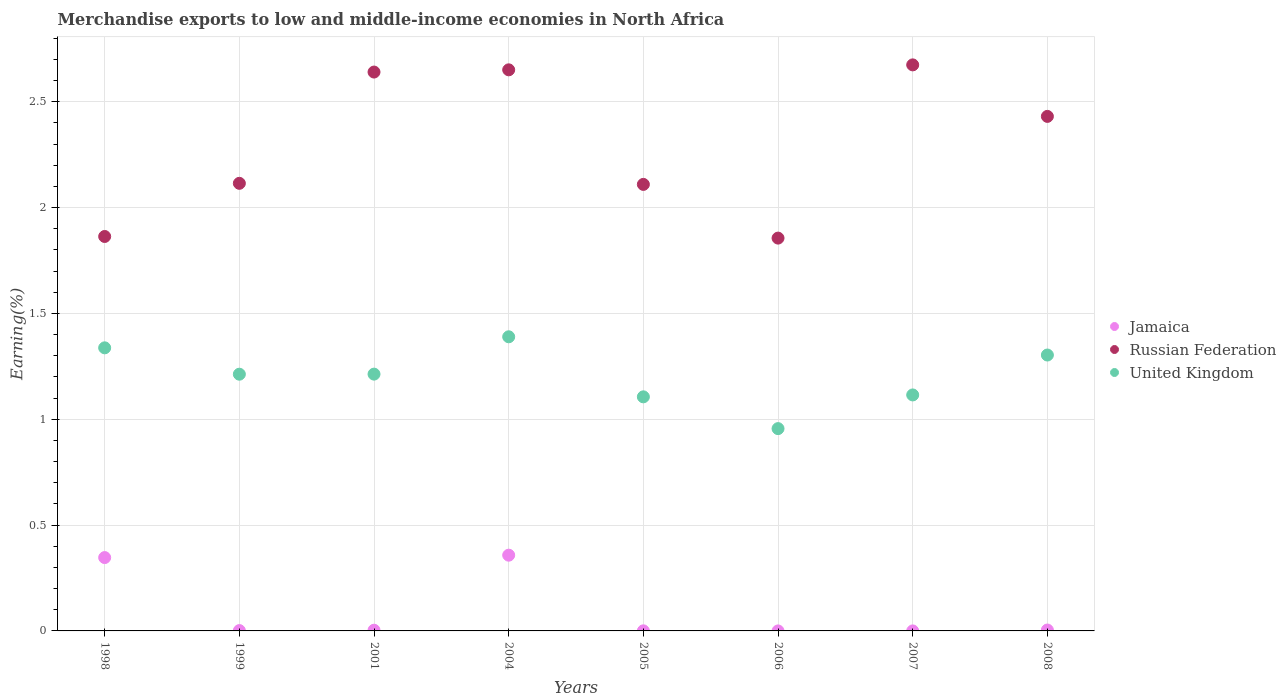What is the percentage of amount earned from merchandise exports in Russian Federation in 2004?
Your response must be concise. 2.65. Across all years, what is the maximum percentage of amount earned from merchandise exports in Russian Federation?
Make the answer very short. 2.67. Across all years, what is the minimum percentage of amount earned from merchandise exports in Jamaica?
Give a very brief answer. 6.24280726533135e-6. In which year was the percentage of amount earned from merchandise exports in Russian Federation maximum?
Offer a terse response. 2007. In which year was the percentage of amount earned from merchandise exports in Russian Federation minimum?
Keep it short and to the point. 2006. What is the total percentage of amount earned from merchandise exports in Jamaica in the graph?
Offer a very short reply. 0.71. What is the difference between the percentage of amount earned from merchandise exports in United Kingdom in 2001 and that in 2004?
Make the answer very short. -0.18. What is the difference between the percentage of amount earned from merchandise exports in Russian Federation in 2006 and the percentage of amount earned from merchandise exports in Jamaica in 1999?
Make the answer very short. 1.85. What is the average percentage of amount earned from merchandise exports in Jamaica per year?
Offer a very short reply. 0.09. In the year 2004, what is the difference between the percentage of amount earned from merchandise exports in Russian Federation and percentage of amount earned from merchandise exports in Jamaica?
Your answer should be compact. 2.29. What is the ratio of the percentage of amount earned from merchandise exports in Russian Federation in 1998 to that in 1999?
Ensure brevity in your answer.  0.88. What is the difference between the highest and the second highest percentage of amount earned from merchandise exports in Russian Federation?
Give a very brief answer. 0.02. What is the difference between the highest and the lowest percentage of amount earned from merchandise exports in Russian Federation?
Ensure brevity in your answer.  0.82. In how many years, is the percentage of amount earned from merchandise exports in Russian Federation greater than the average percentage of amount earned from merchandise exports in Russian Federation taken over all years?
Give a very brief answer. 4. Is the sum of the percentage of amount earned from merchandise exports in Jamaica in 1999 and 2004 greater than the maximum percentage of amount earned from merchandise exports in Russian Federation across all years?
Provide a succinct answer. No. Does the percentage of amount earned from merchandise exports in Russian Federation monotonically increase over the years?
Offer a terse response. No. Is the percentage of amount earned from merchandise exports in Jamaica strictly less than the percentage of amount earned from merchandise exports in Russian Federation over the years?
Provide a short and direct response. Yes. How many dotlines are there?
Offer a terse response. 3. How many years are there in the graph?
Your answer should be very brief. 8. What is the difference between two consecutive major ticks on the Y-axis?
Your answer should be compact. 0.5. Are the values on the major ticks of Y-axis written in scientific E-notation?
Offer a very short reply. No. Does the graph contain any zero values?
Keep it short and to the point. No. Does the graph contain grids?
Your response must be concise. Yes. Where does the legend appear in the graph?
Offer a terse response. Center right. How are the legend labels stacked?
Provide a short and direct response. Vertical. What is the title of the graph?
Your response must be concise. Merchandise exports to low and middle-income economies in North Africa. Does "Czech Republic" appear as one of the legend labels in the graph?
Make the answer very short. No. What is the label or title of the Y-axis?
Keep it short and to the point. Earning(%). What is the Earning(%) of Jamaica in 1998?
Your response must be concise. 0.35. What is the Earning(%) in Russian Federation in 1998?
Make the answer very short. 1.86. What is the Earning(%) of United Kingdom in 1998?
Offer a very short reply. 1.34. What is the Earning(%) in Jamaica in 1999?
Provide a short and direct response. 0. What is the Earning(%) of Russian Federation in 1999?
Make the answer very short. 2.11. What is the Earning(%) of United Kingdom in 1999?
Ensure brevity in your answer.  1.21. What is the Earning(%) of Jamaica in 2001?
Offer a terse response. 0. What is the Earning(%) in Russian Federation in 2001?
Ensure brevity in your answer.  2.64. What is the Earning(%) in United Kingdom in 2001?
Make the answer very short. 1.21. What is the Earning(%) of Jamaica in 2004?
Provide a short and direct response. 0.36. What is the Earning(%) of Russian Federation in 2004?
Make the answer very short. 2.65. What is the Earning(%) of United Kingdom in 2004?
Offer a terse response. 1.39. What is the Earning(%) in Jamaica in 2005?
Your response must be concise. 0. What is the Earning(%) of Russian Federation in 2005?
Offer a terse response. 2.11. What is the Earning(%) in United Kingdom in 2005?
Your response must be concise. 1.11. What is the Earning(%) of Jamaica in 2006?
Your answer should be compact. 6.24280726533135e-6. What is the Earning(%) in Russian Federation in 2006?
Give a very brief answer. 1.86. What is the Earning(%) of United Kingdom in 2006?
Offer a very short reply. 0.96. What is the Earning(%) in Jamaica in 2007?
Provide a short and direct response. 2.32928039792183e-5. What is the Earning(%) in Russian Federation in 2007?
Offer a very short reply. 2.67. What is the Earning(%) in United Kingdom in 2007?
Offer a terse response. 1.11. What is the Earning(%) in Jamaica in 2008?
Give a very brief answer. 0. What is the Earning(%) in Russian Federation in 2008?
Offer a very short reply. 2.43. What is the Earning(%) in United Kingdom in 2008?
Your response must be concise. 1.3. Across all years, what is the maximum Earning(%) in Jamaica?
Your response must be concise. 0.36. Across all years, what is the maximum Earning(%) of Russian Federation?
Your answer should be very brief. 2.67. Across all years, what is the maximum Earning(%) of United Kingdom?
Your answer should be compact. 1.39. Across all years, what is the minimum Earning(%) of Jamaica?
Your response must be concise. 6.24280726533135e-6. Across all years, what is the minimum Earning(%) of Russian Federation?
Ensure brevity in your answer.  1.86. Across all years, what is the minimum Earning(%) in United Kingdom?
Keep it short and to the point. 0.96. What is the total Earning(%) in Jamaica in the graph?
Your answer should be very brief. 0.71. What is the total Earning(%) in Russian Federation in the graph?
Give a very brief answer. 18.34. What is the total Earning(%) of United Kingdom in the graph?
Provide a succinct answer. 9.63. What is the difference between the Earning(%) of Jamaica in 1998 and that in 1999?
Your response must be concise. 0.34. What is the difference between the Earning(%) of Russian Federation in 1998 and that in 1999?
Your response must be concise. -0.25. What is the difference between the Earning(%) of United Kingdom in 1998 and that in 1999?
Give a very brief answer. 0.12. What is the difference between the Earning(%) in Jamaica in 1998 and that in 2001?
Provide a succinct answer. 0.34. What is the difference between the Earning(%) of Russian Federation in 1998 and that in 2001?
Provide a succinct answer. -0.78. What is the difference between the Earning(%) in United Kingdom in 1998 and that in 2001?
Your answer should be compact. 0.12. What is the difference between the Earning(%) in Jamaica in 1998 and that in 2004?
Your answer should be very brief. -0.01. What is the difference between the Earning(%) in Russian Federation in 1998 and that in 2004?
Ensure brevity in your answer.  -0.79. What is the difference between the Earning(%) of United Kingdom in 1998 and that in 2004?
Keep it short and to the point. -0.05. What is the difference between the Earning(%) in Jamaica in 1998 and that in 2005?
Give a very brief answer. 0.35. What is the difference between the Earning(%) of Russian Federation in 1998 and that in 2005?
Your answer should be compact. -0.25. What is the difference between the Earning(%) of United Kingdom in 1998 and that in 2005?
Ensure brevity in your answer.  0.23. What is the difference between the Earning(%) in Jamaica in 1998 and that in 2006?
Give a very brief answer. 0.35. What is the difference between the Earning(%) of Russian Federation in 1998 and that in 2006?
Offer a terse response. 0.01. What is the difference between the Earning(%) in United Kingdom in 1998 and that in 2006?
Your answer should be very brief. 0.38. What is the difference between the Earning(%) in Jamaica in 1998 and that in 2007?
Your response must be concise. 0.35. What is the difference between the Earning(%) in Russian Federation in 1998 and that in 2007?
Your answer should be compact. -0.81. What is the difference between the Earning(%) in United Kingdom in 1998 and that in 2007?
Your answer should be compact. 0.22. What is the difference between the Earning(%) in Jamaica in 1998 and that in 2008?
Your response must be concise. 0.34. What is the difference between the Earning(%) in Russian Federation in 1998 and that in 2008?
Your answer should be compact. -0.57. What is the difference between the Earning(%) of United Kingdom in 1998 and that in 2008?
Make the answer very short. 0.03. What is the difference between the Earning(%) of Jamaica in 1999 and that in 2001?
Your answer should be compact. -0. What is the difference between the Earning(%) in Russian Federation in 1999 and that in 2001?
Give a very brief answer. -0.53. What is the difference between the Earning(%) of United Kingdom in 1999 and that in 2001?
Offer a very short reply. -0. What is the difference between the Earning(%) of Jamaica in 1999 and that in 2004?
Offer a very short reply. -0.36. What is the difference between the Earning(%) in Russian Federation in 1999 and that in 2004?
Your answer should be compact. -0.54. What is the difference between the Earning(%) in United Kingdom in 1999 and that in 2004?
Provide a succinct answer. -0.18. What is the difference between the Earning(%) in Jamaica in 1999 and that in 2005?
Offer a very short reply. 0. What is the difference between the Earning(%) of Russian Federation in 1999 and that in 2005?
Your answer should be compact. 0.01. What is the difference between the Earning(%) in United Kingdom in 1999 and that in 2005?
Your response must be concise. 0.11. What is the difference between the Earning(%) of Jamaica in 1999 and that in 2006?
Your answer should be very brief. 0. What is the difference between the Earning(%) of Russian Federation in 1999 and that in 2006?
Your answer should be compact. 0.26. What is the difference between the Earning(%) of United Kingdom in 1999 and that in 2006?
Offer a very short reply. 0.26. What is the difference between the Earning(%) of Jamaica in 1999 and that in 2007?
Your response must be concise. 0. What is the difference between the Earning(%) in Russian Federation in 1999 and that in 2007?
Ensure brevity in your answer.  -0.56. What is the difference between the Earning(%) of United Kingdom in 1999 and that in 2007?
Offer a terse response. 0.1. What is the difference between the Earning(%) of Jamaica in 1999 and that in 2008?
Offer a very short reply. -0. What is the difference between the Earning(%) of Russian Federation in 1999 and that in 2008?
Provide a succinct answer. -0.32. What is the difference between the Earning(%) in United Kingdom in 1999 and that in 2008?
Ensure brevity in your answer.  -0.09. What is the difference between the Earning(%) of Jamaica in 2001 and that in 2004?
Offer a terse response. -0.35. What is the difference between the Earning(%) of Russian Federation in 2001 and that in 2004?
Your answer should be very brief. -0.01. What is the difference between the Earning(%) in United Kingdom in 2001 and that in 2004?
Offer a terse response. -0.18. What is the difference between the Earning(%) in Jamaica in 2001 and that in 2005?
Provide a short and direct response. 0. What is the difference between the Earning(%) in Russian Federation in 2001 and that in 2005?
Provide a succinct answer. 0.53. What is the difference between the Earning(%) in United Kingdom in 2001 and that in 2005?
Provide a short and direct response. 0.11. What is the difference between the Earning(%) in Jamaica in 2001 and that in 2006?
Your response must be concise. 0. What is the difference between the Earning(%) of Russian Federation in 2001 and that in 2006?
Provide a succinct answer. 0.78. What is the difference between the Earning(%) of United Kingdom in 2001 and that in 2006?
Provide a succinct answer. 0.26. What is the difference between the Earning(%) of Jamaica in 2001 and that in 2007?
Make the answer very short. 0. What is the difference between the Earning(%) in Russian Federation in 2001 and that in 2007?
Offer a very short reply. -0.03. What is the difference between the Earning(%) of United Kingdom in 2001 and that in 2007?
Your response must be concise. 0.1. What is the difference between the Earning(%) in Jamaica in 2001 and that in 2008?
Make the answer very short. -0. What is the difference between the Earning(%) in Russian Federation in 2001 and that in 2008?
Provide a succinct answer. 0.21. What is the difference between the Earning(%) in United Kingdom in 2001 and that in 2008?
Provide a short and direct response. -0.09. What is the difference between the Earning(%) of Jamaica in 2004 and that in 2005?
Provide a short and direct response. 0.36. What is the difference between the Earning(%) of Russian Federation in 2004 and that in 2005?
Offer a very short reply. 0.54. What is the difference between the Earning(%) in United Kingdom in 2004 and that in 2005?
Your answer should be compact. 0.28. What is the difference between the Earning(%) in Jamaica in 2004 and that in 2006?
Keep it short and to the point. 0.36. What is the difference between the Earning(%) in Russian Federation in 2004 and that in 2006?
Your response must be concise. 0.8. What is the difference between the Earning(%) in United Kingdom in 2004 and that in 2006?
Offer a very short reply. 0.43. What is the difference between the Earning(%) of Jamaica in 2004 and that in 2007?
Your answer should be compact. 0.36. What is the difference between the Earning(%) of Russian Federation in 2004 and that in 2007?
Give a very brief answer. -0.02. What is the difference between the Earning(%) in United Kingdom in 2004 and that in 2007?
Ensure brevity in your answer.  0.27. What is the difference between the Earning(%) in Jamaica in 2004 and that in 2008?
Keep it short and to the point. 0.35. What is the difference between the Earning(%) of Russian Federation in 2004 and that in 2008?
Offer a very short reply. 0.22. What is the difference between the Earning(%) in United Kingdom in 2004 and that in 2008?
Your response must be concise. 0.09. What is the difference between the Earning(%) of Jamaica in 2005 and that in 2006?
Provide a short and direct response. 0. What is the difference between the Earning(%) of Russian Federation in 2005 and that in 2006?
Offer a terse response. 0.25. What is the difference between the Earning(%) in United Kingdom in 2005 and that in 2006?
Make the answer very short. 0.15. What is the difference between the Earning(%) of Jamaica in 2005 and that in 2007?
Offer a very short reply. 0. What is the difference between the Earning(%) of Russian Federation in 2005 and that in 2007?
Ensure brevity in your answer.  -0.56. What is the difference between the Earning(%) of United Kingdom in 2005 and that in 2007?
Your answer should be very brief. -0.01. What is the difference between the Earning(%) of Jamaica in 2005 and that in 2008?
Keep it short and to the point. -0. What is the difference between the Earning(%) in Russian Federation in 2005 and that in 2008?
Ensure brevity in your answer.  -0.32. What is the difference between the Earning(%) of United Kingdom in 2005 and that in 2008?
Keep it short and to the point. -0.2. What is the difference between the Earning(%) of Russian Federation in 2006 and that in 2007?
Ensure brevity in your answer.  -0.82. What is the difference between the Earning(%) of United Kingdom in 2006 and that in 2007?
Your response must be concise. -0.16. What is the difference between the Earning(%) in Jamaica in 2006 and that in 2008?
Provide a short and direct response. -0. What is the difference between the Earning(%) of Russian Federation in 2006 and that in 2008?
Your answer should be compact. -0.57. What is the difference between the Earning(%) of United Kingdom in 2006 and that in 2008?
Offer a terse response. -0.35. What is the difference between the Earning(%) of Jamaica in 2007 and that in 2008?
Your answer should be very brief. -0. What is the difference between the Earning(%) of Russian Federation in 2007 and that in 2008?
Offer a very short reply. 0.24. What is the difference between the Earning(%) in United Kingdom in 2007 and that in 2008?
Your response must be concise. -0.19. What is the difference between the Earning(%) in Jamaica in 1998 and the Earning(%) in Russian Federation in 1999?
Keep it short and to the point. -1.77. What is the difference between the Earning(%) of Jamaica in 1998 and the Earning(%) of United Kingdom in 1999?
Keep it short and to the point. -0.87. What is the difference between the Earning(%) of Russian Federation in 1998 and the Earning(%) of United Kingdom in 1999?
Offer a terse response. 0.65. What is the difference between the Earning(%) of Jamaica in 1998 and the Earning(%) of Russian Federation in 2001?
Your answer should be very brief. -2.29. What is the difference between the Earning(%) of Jamaica in 1998 and the Earning(%) of United Kingdom in 2001?
Make the answer very short. -0.87. What is the difference between the Earning(%) in Russian Federation in 1998 and the Earning(%) in United Kingdom in 2001?
Keep it short and to the point. 0.65. What is the difference between the Earning(%) in Jamaica in 1998 and the Earning(%) in Russian Federation in 2004?
Your answer should be compact. -2.3. What is the difference between the Earning(%) in Jamaica in 1998 and the Earning(%) in United Kingdom in 2004?
Offer a terse response. -1.04. What is the difference between the Earning(%) of Russian Federation in 1998 and the Earning(%) of United Kingdom in 2004?
Keep it short and to the point. 0.47. What is the difference between the Earning(%) of Jamaica in 1998 and the Earning(%) of Russian Federation in 2005?
Your response must be concise. -1.76. What is the difference between the Earning(%) of Jamaica in 1998 and the Earning(%) of United Kingdom in 2005?
Make the answer very short. -0.76. What is the difference between the Earning(%) in Russian Federation in 1998 and the Earning(%) in United Kingdom in 2005?
Offer a terse response. 0.76. What is the difference between the Earning(%) of Jamaica in 1998 and the Earning(%) of Russian Federation in 2006?
Offer a terse response. -1.51. What is the difference between the Earning(%) in Jamaica in 1998 and the Earning(%) in United Kingdom in 2006?
Keep it short and to the point. -0.61. What is the difference between the Earning(%) in Russian Federation in 1998 and the Earning(%) in United Kingdom in 2006?
Give a very brief answer. 0.91. What is the difference between the Earning(%) of Jamaica in 1998 and the Earning(%) of Russian Federation in 2007?
Your response must be concise. -2.33. What is the difference between the Earning(%) of Jamaica in 1998 and the Earning(%) of United Kingdom in 2007?
Give a very brief answer. -0.77. What is the difference between the Earning(%) in Russian Federation in 1998 and the Earning(%) in United Kingdom in 2007?
Your answer should be compact. 0.75. What is the difference between the Earning(%) in Jamaica in 1998 and the Earning(%) in Russian Federation in 2008?
Offer a terse response. -2.08. What is the difference between the Earning(%) of Jamaica in 1998 and the Earning(%) of United Kingdom in 2008?
Your answer should be very brief. -0.96. What is the difference between the Earning(%) of Russian Federation in 1998 and the Earning(%) of United Kingdom in 2008?
Provide a short and direct response. 0.56. What is the difference between the Earning(%) of Jamaica in 1999 and the Earning(%) of Russian Federation in 2001?
Offer a terse response. -2.64. What is the difference between the Earning(%) of Jamaica in 1999 and the Earning(%) of United Kingdom in 2001?
Offer a very short reply. -1.21. What is the difference between the Earning(%) of Russian Federation in 1999 and the Earning(%) of United Kingdom in 2001?
Give a very brief answer. 0.9. What is the difference between the Earning(%) of Jamaica in 1999 and the Earning(%) of Russian Federation in 2004?
Keep it short and to the point. -2.65. What is the difference between the Earning(%) of Jamaica in 1999 and the Earning(%) of United Kingdom in 2004?
Give a very brief answer. -1.39. What is the difference between the Earning(%) in Russian Federation in 1999 and the Earning(%) in United Kingdom in 2004?
Offer a very short reply. 0.72. What is the difference between the Earning(%) of Jamaica in 1999 and the Earning(%) of Russian Federation in 2005?
Provide a succinct answer. -2.11. What is the difference between the Earning(%) of Jamaica in 1999 and the Earning(%) of United Kingdom in 2005?
Your answer should be very brief. -1.1. What is the difference between the Earning(%) of Russian Federation in 1999 and the Earning(%) of United Kingdom in 2005?
Offer a very short reply. 1.01. What is the difference between the Earning(%) in Jamaica in 1999 and the Earning(%) in Russian Federation in 2006?
Make the answer very short. -1.85. What is the difference between the Earning(%) of Jamaica in 1999 and the Earning(%) of United Kingdom in 2006?
Your answer should be compact. -0.95. What is the difference between the Earning(%) in Russian Federation in 1999 and the Earning(%) in United Kingdom in 2006?
Give a very brief answer. 1.16. What is the difference between the Earning(%) in Jamaica in 1999 and the Earning(%) in Russian Federation in 2007?
Make the answer very short. -2.67. What is the difference between the Earning(%) in Jamaica in 1999 and the Earning(%) in United Kingdom in 2007?
Offer a very short reply. -1.11. What is the difference between the Earning(%) of Jamaica in 1999 and the Earning(%) of Russian Federation in 2008?
Provide a short and direct response. -2.43. What is the difference between the Earning(%) of Jamaica in 1999 and the Earning(%) of United Kingdom in 2008?
Your answer should be very brief. -1.3. What is the difference between the Earning(%) of Russian Federation in 1999 and the Earning(%) of United Kingdom in 2008?
Your answer should be compact. 0.81. What is the difference between the Earning(%) of Jamaica in 2001 and the Earning(%) of Russian Federation in 2004?
Provide a short and direct response. -2.65. What is the difference between the Earning(%) in Jamaica in 2001 and the Earning(%) in United Kingdom in 2004?
Offer a terse response. -1.39. What is the difference between the Earning(%) in Russian Federation in 2001 and the Earning(%) in United Kingdom in 2004?
Provide a succinct answer. 1.25. What is the difference between the Earning(%) in Jamaica in 2001 and the Earning(%) in Russian Federation in 2005?
Provide a succinct answer. -2.11. What is the difference between the Earning(%) of Jamaica in 2001 and the Earning(%) of United Kingdom in 2005?
Offer a very short reply. -1.1. What is the difference between the Earning(%) in Russian Federation in 2001 and the Earning(%) in United Kingdom in 2005?
Offer a very short reply. 1.53. What is the difference between the Earning(%) in Jamaica in 2001 and the Earning(%) in Russian Federation in 2006?
Provide a short and direct response. -1.85. What is the difference between the Earning(%) of Jamaica in 2001 and the Earning(%) of United Kingdom in 2006?
Ensure brevity in your answer.  -0.95. What is the difference between the Earning(%) in Russian Federation in 2001 and the Earning(%) in United Kingdom in 2006?
Provide a succinct answer. 1.68. What is the difference between the Earning(%) in Jamaica in 2001 and the Earning(%) in Russian Federation in 2007?
Offer a very short reply. -2.67. What is the difference between the Earning(%) of Jamaica in 2001 and the Earning(%) of United Kingdom in 2007?
Ensure brevity in your answer.  -1.11. What is the difference between the Earning(%) of Russian Federation in 2001 and the Earning(%) of United Kingdom in 2007?
Offer a terse response. 1.53. What is the difference between the Earning(%) in Jamaica in 2001 and the Earning(%) in Russian Federation in 2008?
Your response must be concise. -2.43. What is the difference between the Earning(%) in Jamaica in 2001 and the Earning(%) in United Kingdom in 2008?
Provide a succinct answer. -1.3. What is the difference between the Earning(%) of Russian Federation in 2001 and the Earning(%) of United Kingdom in 2008?
Provide a succinct answer. 1.34. What is the difference between the Earning(%) of Jamaica in 2004 and the Earning(%) of Russian Federation in 2005?
Make the answer very short. -1.75. What is the difference between the Earning(%) in Jamaica in 2004 and the Earning(%) in United Kingdom in 2005?
Give a very brief answer. -0.75. What is the difference between the Earning(%) in Russian Federation in 2004 and the Earning(%) in United Kingdom in 2005?
Provide a succinct answer. 1.54. What is the difference between the Earning(%) in Jamaica in 2004 and the Earning(%) in Russian Federation in 2006?
Keep it short and to the point. -1.5. What is the difference between the Earning(%) of Jamaica in 2004 and the Earning(%) of United Kingdom in 2006?
Ensure brevity in your answer.  -0.6. What is the difference between the Earning(%) in Russian Federation in 2004 and the Earning(%) in United Kingdom in 2006?
Offer a very short reply. 1.7. What is the difference between the Earning(%) in Jamaica in 2004 and the Earning(%) in Russian Federation in 2007?
Your response must be concise. -2.32. What is the difference between the Earning(%) of Jamaica in 2004 and the Earning(%) of United Kingdom in 2007?
Your response must be concise. -0.76. What is the difference between the Earning(%) of Russian Federation in 2004 and the Earning(%) of United Kingdom in 2007?
Your answer should be compact. 1.54. What is the difference between the Earning(%) in Jamaica in 2004 and the Earning(%) in Russian Federation in 2008?
Provide a succinct answer. -2.07. What is the difference between the Earning(%) in Jamaica in 2004 and the Earning(%) in United Kingdom in 2008?
Your response must be concise. -0.95. What is the difference between the Earning(%) of Russian Federation in 2004 and the Earning(%) of United Kingdom in 2008?
Offer a very short reply. 1.35. What is the difference between the Earning(%) of Jamaica in 2005 and the Earning(%) of Russian Federation in 2006?
Your response must be concise. -1.86. What is the difference between the Earning(%) in Jamaica in 2005 and the Earning(%) in United Kingdom in 2006?
Your answer should be compact. -0.96. What is the difference between the Earning(%) in Russian Federation in 2005 and the Earning(%) in United Kingdom in 2006?
Your answer should be very brief. 1.15. What is the difference between the Earning(%) of Jamaica in 2005 and the Earning(%) of Russian Federation in 2007?
Your answer should be very brief. -2.67. What is the difference between the Earning(%) in Jamaica in 2005 and the Earning(%) in United Kingdom in 2007?
Make the answer very short. -1.11. What is the difference between the Earning(%) of Jamaica in 2005 and the Earning(%) of Russian Federation in 2008?
Provide a succinct answer. -2.43. What is the difference between the Earning(%) in Jamaica in 2005 and the Earning(%) in United Kingdom in 2008?
Your answer should be compact. -1.3. What is the difference between the Earning(%) of Russian Federation in 2005 and the Earning(%) of United Kingdom in 2008?
Make the answer very short. 0.81. What is the difference between the Earning(%) in Jamaica in 2006 and the Earning(%) in Russian Federation in 2007?
Keep it short and to the point. -2.67. What is the difference between the Earning(%) of Jamaica in 2006 and the Earning(%) of United Kingdom in 2007?
Offer a very short reply. -1.11. What is the difference between the Earning(%) of Russian Federation in 2006 and the Earning(%) of United Kingdom in 2007?
Your answer should be compact. 0.74. What is the difference between the Earning(%) of Jamaica in 2006 and the Earning(%) of Russian Federation in 2008?
Keep it short and to the point. -2.43. What is the difference between the Earning(%) of Jamaica in 2006 and the Earning(%) of United Kingdom in 2008?
Provide a short and direct response. -1.3. What is the difference between the Earning(%) of Russian Federation in 2006 and the Earning(%) of United Kingdom in 2008?
Offer a terse response. 0.55. What is the difference between the Earning(%) in Jamaica in 2007 and the Earning(%) in Russian Federation in 2008?
Offer a very short reply. -2.43. What is the difference between the Earning(%) in Jamaica in 2007 and the Earning(%) in United Kingdom in 2008?
Provide a succinct answer. -1.3. What is the difference between the Earning(%) in Russian Federation in 2007 and the Earning(%) in United Kingdom in 2008?
Your response must be concise. 1.37. What is the average Earning(%) in Jamaica per year?
Your response must be concise. 0.09. What is the average Earning(%) of Russian Federation per year?
Make the answer very short. 2.29. What is the average Earning(%) of United Kingdom per year?
Your answer should be very brief. 1.2. In the year 1998, what is the difference between the Earning(%) of Jamaica and Earning(%) of Russian Federation?
Your response must be concise. -1.52. In the year 1998, what is the difference between the Earning(%) of Jamaica and Earning(%) of United Kingdom?
Provide a succinct answer. -0.99. In the year 1998, what is the difference between the Earning(%) in Russian Federation and Earning(%) in United Kingdom?
Keep it short and to the point. 0.53. In the year 1999, what is the difference between the Earning(%) in Jamaica and Earning(%) in Russian Federation?
Give a very brief answer. -2.11. In the year 1999, what is the difference between the Earning(%) of Jamaica and Earning(%) of United Kingdom?
Ensure brevity in your answer.  -1.21. In the year 1999, what is the difference between the Earning(%) of Russian Federation and Earning(%) of United Kingdom?
Make the answer very short. 0.9. In the year 2001, what is the difference between the Earning(%) of Jamaica and Earning(%) of Russian Federation?
Offer a very short reply. -2.64. In the year 2001, what is the difference between the Earning(%) of Jamaica and Earning(%) of United Kingdom?
Your answer should be very brief. -1.21. In the year 2001, what is the difference between the Earning(%) in Russian Federation and Earning(%) in United Kingdom?
Keep it short and to the point. 1.43. In the year 2004, what is the difference between the Earning(%) of Jamaica and Earning(%) of Russian Federation?
Ensure brevity in your answer.  -2.29. In the year 2004, what is the difference between the Earning(%) in Jamaica and Earning(%) in United Kingdom?
Offer a very short reply. -1.03. In the year 2004, what is the difference between the Earning(%) of Russian Federation and Earning(%) of United Kingdom?
Offer a terse response. 1.26. In the year 2005, what is the difference between the Earning(%) in Jamaica and Earning(%) in Russian Federation?
Your response must be concise. -2.11. In the year 2005, what is the difference between the Earning(%) in Jamaica and Earning(%) in United Kingdom?
Ensure brevity in your answer.  -1.11. In the year 2005, what is the difference between the Earning(%) in Russian Federation and Earning(%) in United Kingdom?
Ensure brevity in your answer.  1. In the year 2006, what is the difference between the Earning(%) of Jamaica and Earning(%) of Russian Federation?
Your response must be concise. -1.86. In the year 2006, what is the difference between the Earning(%) in Jamaica and Earning(%) in United Kingdom?
Your response must be concise. -0.96. In the year 2006, what is the difference between the Earning(%) of Russian Federation and Earning(%) of United Kingdom?
Give a very brief answer. 0.9. In the year 2007, what is the difference between the Earning(%) in Jamaica and Earning(%) in Russian Federation?
Your response must be concise. -2.67. In the year 2007, what is the difference between the Earning(%) of Jamaica and Earning(%) of United Kingdom?
Ensure brevity in your answer.  -1.11. In the year 2007, what is the difference between the Earning(%) in Russian Federation and Earning(%) in United Kingdom?
Your response must be concise. 1.56. In the year 2008, what is the difference between the Earning(%) of Jamaica and Earning(%) of Russian Federation?
Give a very brief answer. -2.43. In the year 2008, what is the difference between the Earning(%) of Jamaica and Earning(%) of United Kingdom?
Your response must be concise. -1.3. In the year 2008, what is the difference between the Earning(%) of Russian Federation and Earning(%) of United Kingdom?
Give a very brief answer. 1.13. What is the ratio of the Earning(%) of Jamaica in 1998 to that in 1999?
Your answer should be compact. 222.04. What is the ratio of the Earning(%) in Russian Federation in 1998 to that in 1999?
Your answer should be very brief. 0.88. What is the ratio of the Earning(%) of United Kingdom in 1998 to that in 1999?
Offer a terse response. 1.1. What is the ratio of the Earning(%) in Jamaica in 1998 to that in 2001?
Ensure brevity in your answer.  102.52. What is the ratio of the Earning(%) of Russian Federation in 1998 to that in 2001?
Provide a short and direct response. 0.71. What is the ratio of the Earning(%) of United Kingdom in 1998 to that in 2001?
Provide a short and direct response. 1.1. What is the ratio of the Earning(%) of Jamaica in 1998 to that in 2004?
Provide a short and direct response. 0.97. What is the ratio of the Earning(%) in Russian Federation in 1998 to that in 2004?
Provide a succinct answer. 0.7. What is the ratio of the Earning(%) in United Kingdom in 1998 to that in 2004?
Ensure brevity in your answer.  0.96. What is the ratio of the Earning(%) of Jamaica in 1998 to that in 2005?
Offer a terse response. 878.9. What is the ratio of the Earning(%) of Russian Federation in 1998 to that in 2005?
Give a very brief answer. 0.88. What is the ratio of the Earning(%) in United Kingdom in 1998 to that in 2005?
Your answer should be very brief. 1.21. What is the ratio of the Earning(%) in Jamaica in 1998 to that in 2006?
Your response must be concise. 5.55e+04. What is the ratio of the Earning(%) of United Kingdom in 1998 to that in 2006?
Ensure brevity in your answer.  1.4. What is the ratio of the Earning(%) of Jamaica in 1998 to that in 2007?
Give a very brief answer. 1.49e+04. What is the ratio of the Earning(%) in Russian Federation in 1998 to that in 2007?
Offer a terse response. 0.7. What is the ratio of the Earning(%) of United Kingdom in 1998 to that in 2007?
Your response must be concise. 1.2. What is the ratio of the Earning(%) of Jamaica in 1998 to that in 2008?
Provide a succinct answer. 81.05. What is the ratio of the Earning(%) in Russian Federation in 1998 to that in 2008?
Your answer should be compact. 0.77. What is the ratio of the Earning(%) in United Kingdom in 1998 to that in 2008?
Your response must be concise. 1.03. What is the ratio of the Earning(%) of Jamaica in 1999 to that in 2001?
Offer a terse response. 0.46. What is the ratio of the Earning(%) in Russian Federation in 1999 to that in 2001?
Offer a terse response. 0.8. What is the ratio of the Earning(%) of United Kingdom in 1999 to that in 2001?
Offer a terse response. 1. What is the ratio of the Earning(%) in Jamaica in 1999 to that in 2004?
Make the answer very short. 0. What is the ratio of the Earning(%) of Russian Federation in 1999 to that in 2004?
Your answer should be very brief. 0.8. What is the ratio of the Earning(%) in United Kingdom in 1999 to that in 2004?
Keep it short and to the point. 0.87. What is the ratio of the Earning(%) in Jamaica in 1999 to that in 2005?
Provide a succinct answer. 3.96. What is the ratio of the Earning(%) in Russian Federation in 1999 to that in 2005?
Make the answer very short. 1. What is the ratio of the Earning(%) in United Kingdom in 1999 to that in 2005?
Offer a terse response. 1.1. What is the ratio of the Earning(%) of Jamaica in 1999 to that in 2006?
Provide a short and direct response. 249.97. What is the ratio of the Earning(%) of Russian Federation in 1999 to that in 2006?
Your response must be concise. 1.14. What is the ratio of the Earning(%) in United Kingdom in 1999 to that in 2006?
Your answer should be compact. 1.27. What is the ratio of the Earning(%) in Jamaica in 1999 to that in 2007?
Your response must be concise. 67. What is the ratio of the Earning(%) in Russian Federation in 1999 to that in 2007?
Ensure brevity in your answer.  0.79. What is the ratio of the Earning(%) of United Kingdom in 1999 to that in 2007?
Provide a succinct answer. 1.09. What is the ratio of the Earning(%) of Jamaica in 1999 to that in 2008?
Provide a short and direct response. 0.36. What is the ratio of the Earning(%) of Russian Federation in 1999 to that in 2008?
Offer a terse response. 0.87. What is the ratio of the Earning(%) of United Kingdom in 1999 to that in 2008?
Provide a succinct answer. 0.93. What is the ratio of the Earning(%) in Jamaica in 2001 to that in 2004?
Give a very brief answer. 0.01. What is the ratio of the Earning(%) in United Kingdom in 2001 to that in 2004?
Your answer should be compact. 0.87. What is the ratio of the Earning(%) in Jamaica in 2001 to that in 2005?
Ensure brevity in your answer.  8.57. What is the ratio of the Earning(%) in Russian Federation in 2001 to that in 2005?
Provide a succinct answer. 1.25. What is the ratio of the Earning(%) of United Kingdom in 2001 to that in 2005?
Your response must be concise. 1.1. What is the ratio of the Earning(%) in Jamaica in 2001 to that in 2006?
Make the answer very short. 541.41. What is the ratio of the Earning(%) in Russian Federation in 2001 to that in 2006?
Ensure brevity in your answer.  1.42. What is the ratio of the Earning(%) in United Kingdom in 2001 to that in 2006?
Provide a short and direct response. 1.27. What is the ratio of the Earning(%) in Jamaica in 2001 to that in 2007?
Provide a succinct answer. 145.11. What is the ratio of the Earning(%) in Russian Federation in 2001 to that in 2007?
Your answer should be compact. 0.99. What is the ratio of the Earning(%) in United Kingdom in 2001 to that in 2007?
Your answer should be compact. 1.09. What is the ratio of the Earning(%) in Jamaica in 2001 to that in 2008?
Your answer should be compact. 0.79. What is the ratio of the Earning(%) in Russian Federation in 2001 to that in 2008?
Ensure brevity in your answer.  1.09. What is the ratio of the Earning(%) of United Kingdom in 2001 to that in 2008?
Provide a short and direct response. 0.93. What is the ratio of the Earning(%) of Jamaica in 2004 to that in 2005?
Provide a short and direct response. 907.62. What is the ratio of the Earning(%) of Russian Federation in 2004 to that in 2005?
Your answer should be compact. 1.26. What is the ratio of the Earning(%) of United Kingdom in 2004 to that in 2005?
Offer a very short reply. 1.26. What is the ratio of the Earning(%) of Jamaica in 2004 to that in 2006?
Offer a very short reply. 5.73e+04. What is the ratio of the Earning(%) in Russian Federation in 2004 to that in 2006?
Ensure brevity in your answer.  1.43. What is the ratio of the Earning(%) of United Kingdom in 2004 to that in 2006?
Ensure brevity in your answer.  1.45. What is the ratio of the Earning(%) in Jamaica in 2004 to that in 2007?
Provide a succinct answer. 1.54e+04. What is the ratio of the Earning(%) in United Kingdom in 2004 to that in 2007?
Offer a very short reply. 1.25. What is the ratio of the Earning(%) of Jamaica in 2004 to that in 2008?
Your answer should be very brief. 83.69. What is the ratio of the Earning(%) of Russian Federation in 2004 to that in 2008?
Make the answer very short. 1.09. What is the ratio of the Earning(%) in United Kingdom in 2004 to that in 2008?
Make the answer very short. 1.07. What is the ratio of the Earning(%) of Jamaica in 2005 to that in 2006?
Make the answer very short. 63.15. What is the ratio of the Earning(%) of Russian Federation in 2005 to that in 2006?
Your response must be concise. 1.14. What is the ratio of the Earning(%) in United Kingdom in 2005 to that in 2006?
Make the answer very short. 1.16. What is the ratio of the Earning(%) of Jamaica in 2005 to that in 2007?
Keep it short and to the point. 16.93. What is the ratio of the Earning(%) of Russian Federation in 2005 to that in 2007?
Your answer should be very brief. 0.79. What is the ratio of the Earning(%) of Jamaica in 2005 to that in 2008?
Give a very brief answer. 0.09. What is the ratio of the Earning(%) in Russian Federation in 2005 to that in 2008?
Ensure brevity in your answer.  0.87. What is the ratio of the Earning(%) of United Kingdom in 2005 to that in 2008?
Make the answer very short. 0.85. What is the ratio of the Earning(%) of Jamaica in 2006 to that in 2007?
Your answer should be compact. 0.27. What is the ratio of the Earning(%) in Russian Federation in 2006 to that in 2007?
Your answer should be very brief. 0.69. What is the ratio of the Earning(%) of United Kingdom in 2006 to that in 2007?
Your response must be concise. 0.86. What is the ratio of the Earning(%) of Jamaica in 2006 to that in 2008?
Ensure brevity in your answer.  0. What is the ratio of the Earning(%) of Russian Federation in 2006 to that in 2008?
Provide a short and direct response. 0.76. What is the ratio of the Earning(%) of United Kingdom in 2006 to that in 2008?
Offer a very short reply. 0.73. What is the ratio of the Earning(%) in Jamaica in 2007 to that in 2008?
Make the answer very short. 0.01. What is the ratio of the Earning(%) in Russian Federation in 2007 to that in 2008?
Provide a succinct answer. 1.1. What is the ratio of the Earning(%) of United Kingdom in 2007 to that in 2008?
Give a very brief answer. 0.86. What is the difference between the highest and the second highest Earning(%) of Jamaica?
Make the answer very short. 0.01. What is the difference between the highest and the second highest Earning(%) in Russian Federation?
Make the answer very short. 0.02. What is the difference between the highest and the second highest Earning(%) in United Kingdom?
Give a very brief answer. 0.05. What is the difference between the highest and the lowest Earning(%) in Jamaica?
Offer a very short reply. 0.36. What is the difference between the highest and the lowest Earning(%) in Russian Federation?
Offer a terse response. 0.82. What is the difference between the highest and the lowest Earning(%) in United Kingdom?
Ensure brevity in your answer.  0.43. 